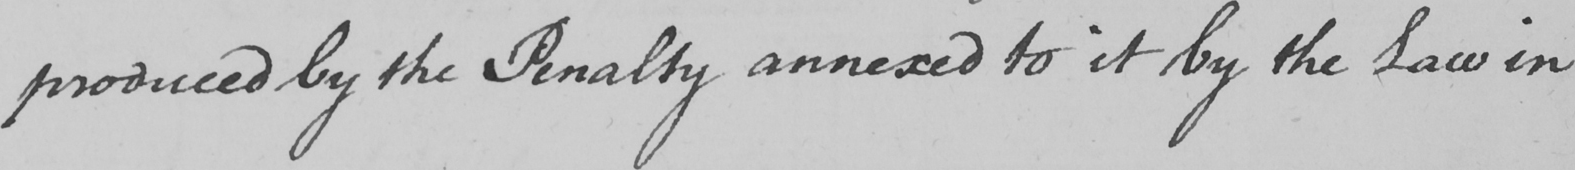Transcribe the text shown in this historical manuscript line. produced by the Penalty annexed to it by the Law in 